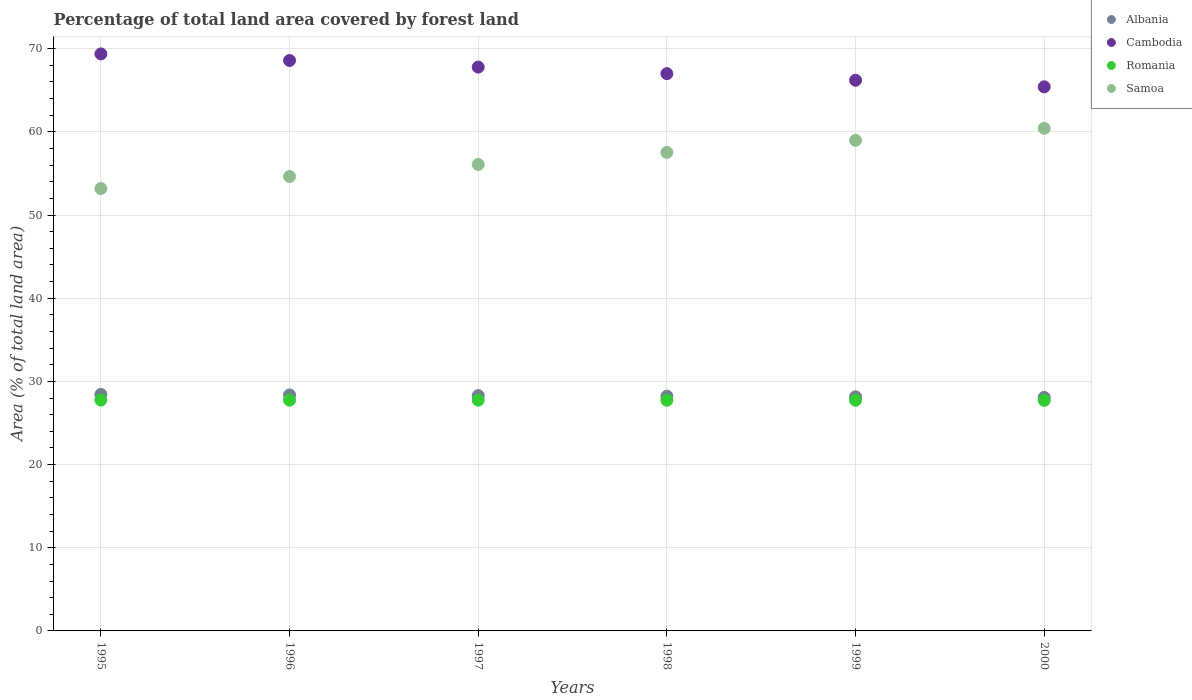How many different coloured dotlines are there?
Offer a terse response. 4. Is the number of dotlines equal to the number of legend labels?
Your answer should be compact. Yes. What is the percentage of forest land in Romania in 1998?
Offer a very short reply. 27.73. Across all years, what is the maximum percentage of forest land in Samoa?
Provide a short and direct response. 60.42. Across all years, what is the minimum percentage of forest land in Cambodia?
Keep it short and to the point. 65.41. What is the total percentage of forest land in Romania in the graph?
Your answer should be very brief. 166.41. What is the difference between the percentage of forest land in Cambodia in 1996 and that in 1997?
Give a very brief answer. 0.79. What is the difference between the percentage of forest land in Samoa in 1998 and the percentage of forest land in Cambodia in 1996?
Make the answer very short. -11.05. What is the average percentage of forest land in Albania per year?
Offer a very short reply. 28.25. In the year 1995, what is the difference between the percentage of forest land in Albania and percentage of forest land in Samoa?
Your answer should be very brief. -24.75. In how many years, is the percentage of forest land in Cambodia greater than 20 %?
Keep it short and to the point. 6. What is the ratio of the percentage of forest land in Samoa in 1995 to that in 1997?
Your answer should be compact. 0.95. Is the percentage of forest land in Samoa in 1995 less than that in 1999?
Offer a very short reply. Yes. Is the difference between the percentage of forest land in Albania in 1995 and 1998 greater than the difference between the percentage of forest land in Samoa in 1995 and 1998?
Make the answer very short. Yes. What is the difference between the highest and the second highest percentage of forest land in Cambodia?
Make the answer very short. 0.79. What is the difference between the highest and the lowest percentage of forest land in Cambodia?
Provide a succinct answer. 3.96. Is the sum of the percentage of forest land in Samoa in 1995 and 1997 greater than the maximum percentage of forest land in Albania across all years?
Offer a terse response. Yes. Is it the case that in every year, the sum of the percentage of forest land in Romania and percentage of forest land in Albania  is greater than the percentage of forest land in Cambodia?
Your answer should be very brief. No. Does the percentage of forest land in Albania monotonically increase over the years?
Your answer should be very brief. No. Is the percentage of forest land in Samoa strictly greater than the percentage of forest land in Romania over the years?
Keep it short and to the point. Yes. How many years are there in the graph?
Offer a very short reply. 6. Where does the legend appear in the graph?
Give a very brief answer. Top right. How are the legend labels stacked?
Your response must be concise. Vertical. What is the title of the graph?
Your answer should be compact. Percentage of total land area covered by forest land. Does "Somalia" appear as one of the legend labels in the graph?
Offer a terse response. No. What is the label or title of the X-axis?
Keep it short and to the point. Years. What is the label or title of the Y-axis?
Provide a short and direct response. Area (% of total land area). What is the Area (% of total land area) of Albania in 1995?
Provide a succinct answer. 28.43. What is the Area (% of total land area) of Cambodia in 1995?
Your answer should be compact. 69.37. What is the Area (% of total land area) of Romania in 1995?
Provide a short and direct response. 27.75. What is the Area (% of total land area) of Samoa in 1995?
Keep it short and to the point. 53.18. What is the Area (% of total land area) in Albania in 1996?
Your answer should be very brief. 28.36. What is the Area (% of total land area) of Cambodia in 1996?
Offer a very short reply. 68.58. What is the Area (% of total land area) of Romania in 1996?
Ensure brevity in your answer.  27.74. What is the Area (% of total land area) of Samoa in 1996?
Keep it short and to the point. 54.63. What is the Area (% of total land area) of Albania in 1997?
Offer a terse response. 28.29. What is the Area (% of total land area) of Cambodia in 1997?
Ensure brevity in your answer.  67.78. What is the Area (% of total land area) in Romania in 1997?
Offer a very short reply. 27.74. What is the Area (% of total land area) of Samoa in 1997?
Offer a very short reply. 56.08. What is the Area (% of total land area) in Albania in 1998?
Offer a very short reply. 28.22. What is the Area (% of total land area) of Cambodia in 1998?
Ensure brevity in your answer.  66.99. What is the Area (% of total land area) in Romania in 1998?
Your response must be concise. 27.73. What is the Area (% of total land area) in Samoa in 1998?
Give a very brief answer. 57.53. What is the Area (% of total land area) of Albania in 1999?
Ensure brevity in your answer.  28.15. What is the Area (% of total land area) of Cambodia in 1999?
Provide a succinct answer. 66.2. What is the Area (% of total land area) in Romania in 1999?
Give a very brief answer. 27.73. What is the Area (% of total land area) in Samoa in 1999?
Offer a very short reply. 58.98. What is the Area (% of total land area) of Albania in 2000?
Provide a short and direct response. 28.08. What is the Area (% of total land area) in Cambodia in 2000?
Your response must be concise. 65.41. What is the Area (% of total land area) of Romania in 2000?
Keep it short and to the point. 27.71. What is the Area (% of total land area) of Samoa in 2000?
Provide a short and direct response. 60.42. Across all years, what is the maximum Area (% of total land area) of Albania?
Give a very brief answer. 28.43. Across all years, what is the maximum Area (% of total land area) of Cambodia?
Your response must be concise. 69.37. Across all years, what is the maximum Area (% of total land area) of Romania?
Your answer should be very brief. 27.75. Across all years, what is the maximum Area (% of total land area) of Samoa?
Provide a succinct answer. 60.42. Across all years, what is the minimum Area (% of total land area) of Albania?
Offer a terse response. 28.08. Across all years, what is the minimum Area (% of total land area) of Cambodia?
Your answer should be very brief. 65.41. Across all years, what is the minimum Area (% of total land area) of Romania?
Offer a terse response. 27.71. Across all years, what is the minimum Area (% of total land area) in Samoa?
Offer a terse response. 53.18. What is the total Area (% of total land area) of Albania in the graph?
Your answer should be very brief. 169.53. What is the total Area (% of total land area) of Cambodia in the graph?
Your response must be concise. 404.33. What is the total Area (% of total land area) in Romania in the graph?
Keep it short and to the point. 166.41. What is the total Area (% of total land area) in Samoa in the graph?
Make the answer very short. 340.81. What is the difference between the Area (% of total land area) in Albania in 1995 and that in 1996?
Provide a short and direct response. 0.07. What is the difference between the Area (% of total land area) of Cambodia in 1995 and that in 1996?
Make the answer very short. 0.79. What is the difference between the Area (% of total land area) of Romania in 1995 and that in 1996?
Offer a terse response. 0.01. What is the difference between the Area (% of total land area) of Samoa in 1995 and that in 1996?
Your answer should be compact. -1.45. What is the difference between the Area (% of total land area) in Albania in 1995 and that in 1997?
Offer a terse response. 0.14. What is the difference between the Area (% of total land area) of Cambodia in 1995 and that in 1997?
Offer a terse response. 1.58. What is the difference between the Area (% of total land area) in Romania in 1995 and that in 1997?
Give a very brief answer. 0.01. What is the difference between the Area (% of total land area) in Samoa in 1995 and that in 1997?
Make the answer very short. -2.9. What is the difference between the Area (% of total land area) in Albania in 1995 and that in 1998?
Give a very brief answer. 0.21. What is the difference between the Area (% of total land area) of Cambodia in 1995 and that in 1998?
Give a very brief answer. 2.38. What is the difference between the Area (% of total land area) in Romania in 1995 and that in 1998?
Your answer should be compact. 0.02. What is the difference between the Area (% of total land area) in Samoa in 1995 and that in 1998?
Offer a very short reply. -4.35. What is the difference between the Area (% of total land area) in Albania in 1995 and that in 1999?
Make the answer very short. 0.28. What is the difference between the Area (% of total land area) of Cambodia in 1995 and that in 1999?
Your answer should be very brief. 3.17. What is the difference between the Area (% of total land area) in Romania in 1995 and that in 1999?
Make the answer very short. 0.02. What is the difference between the Area (% of total land area) of Samoa in 1995 and that in 1999?
Give a very brief answer. -5.8. What is the difference between the Area (% of total land area) in Albania in 1995 and that in 2000?
Provide a succinct answer. 0.36. What is the difference between the Area (% of total land area) of Cambodia in 1995 and that in 2000?
Your answer should be compact. 3.96. What is the difference between the Area (% of total land area) in Romania in 1995 and that in 2000?
Your response must be concise. 0.04. What is the difference between the Area (% of total land area) in Samoa in 1995 and that in 2000?
Your response must be concise. -7.24. What is the difference between the Area (% of total land area) of Albania in 1996 and that in 1997?
Your answer should be very brief. 0.07. What is the difference between the Area (% of total land area) in Cambodia in 1996 and that in 1997?
Offer a very short reply. 0.79. What is the difference between the Area (% of total land area) in Romania in 1996 and that in 1997?
Keep it short and to the point. 0. What is the difference between the Area (% of total land area) in Samoa in 1996 and that in 1997?
Your response must be concise. -1.45. What is the difference between the Area (% of total land area) of Albania in 1996 and that in 1998?
Your response must be concise. 0.14. What is the difference between the Area (% of total land area) in Cambodia in 1996 and that in 1998?
Your answer should be very brief. 1.58. What is the difference between the Area (% of total land area) in Romania in 1996 and that in 1998?
Your answer should be compact. 0.01. What is the difference between the Area (% of total land area) in Samoa in 1996 and that in 1998?
Your answer should be very brief. -2.9. What is the difference between the Area (% of total land area) in Albania in 1996 and that in 1999?
Give a very brief answer. 0.21. What is the difference between the Area (% of total land area) in Cambodia in 1996 and that in 1999?
Provide a short and direct response. 2.38. What is the difference between the Area (% of total land area) of Romania in 1996 and that in 1999?
Provide a short and direct response. 0.02. What is the difference between the Area (% of total land area) of Samoa in 1996 and that in 1999?
Your response must be concise. -4.35. What is the difference between the Area (% of total land area) of Albania in 1996 and that in 2000?
Provide a succinct answer. 0.28. What is the difference between the Area (% of total land area) of Cambodia in 1996 and that in 2000?
Offer a very short reply. 3.17. What is the difference between the Area (% of total land area) of Romania in 1996 and that in 2000?
Your response must be concise. 0.03. What is the difference between the Area (% of total land area) of Samoa in 1996 and that in 2000?
Ensure brevity in your answer.  -5.8. What is the difference between the Area (% of total land area) in Albania in 1997 and that in 1998?
Keep it short and to the point. 0.07. What is the difference between the Area (% of total land area) in Cambodia in 1997 and that in 1998?
Provide a short and direct response. 0.79. What is the difference between the Area (% of total land area) of Romania in 1997 and that in 1998?
Make the answer very short. 0.01. What is the difference between the Area (% of total land area) of Samoa in 1997 and that in 1998?
Make the answer very short. -1.45. What is the difference between the Area (% of total land area) of Albania in 1997 and that in 1999?
Make the answer very short. 0.14. What is the difference between the Area (% of total land area) in Cambodia in 1997 and that in 1999?
Your answer should be very brief. 1.58. What is the difference between the Area (% of total land area) in Romania in 1997 and that in 1999?
Your answer should be very brief. 0.01. What is the difference between the Area (% of total land area) in Samoa in 1997 and that in 1999?
Your response must be concise. -2.9. What is the difference between the Area (% of total land area) of Albania in 1997 and that in 2000?
Give a very brief answer. 0.21. What is the difference between the Area (% of total land area) of Cambodia in 1997 and that in 2000?
Your answer should be compact. 2.38. What is the difference between the Area (% of total land area) in Romania in 1997 and that in 2000?
Provide a succinct answer. 0.03. What is the difference between the Area (% of total land area) of Samoa in 1997 and that in 2000?
Your response must be concise. -4.35. What is the difference between the Area (% of total land area) of Albania in 1998 and that in 1999?
Provide a short and direct response. 0.07. What is the difference between the Area (% of total land area) in Cambodia in 1998 and that in 1999?
Provide a succinct answer. 0.79. What is the difference between the Area (% of total land area) in Romania in 1998 and that in 1999?
Keep it short and to the point. 0. What is the difference between the Area (% of total land area) in Samoa in 1998 and that in 1999?
Your response must be concise. -1.45. What is the difference between the Area (% of total land area) of Albania in 1998 and that in 2000?
Provide a short and direct response. 0.14. What is the difference between the Area (% of total land area) of Cambodia in 1998 and that in 2000?
Ensure brevity in your answer.  1.58. What is the difference between the Area (% of total land area) in Romania in 1998 and that in 2000?
Ensure brevity in your answer.  0.02. What is the difference between the Area (% of total land area) in Samoa in 1998 and that in 2000?
Offer a very short reply. -2.9. What is the difference between the Area (% of total land area) of Albania in 1999 and that in 2000?
Your answer should be very brief. 0.07. What is the difference between the Area (% of total land area) of Cambodia in 1999 and that in 2000?
Offer a very short reply. 0.79. What is the difference between the Area (% of total land area) of Romania in 1999 and that in 2000?
Make the answer very short. 0.02. What is the difference between the Area (% of total land area) of Samoa in 1999 and that in 2000?
Make the answer very short. -1.45. What is the difference between the Area (% of total land area) in Albania in 1995 and the Area (% of total land area) in Cambodia in 1996?
Offer a terse response. -40.14. What is the difference between the Area (% of total land area) in Albania in 1995 and the Area (% of total land area) in Romania in 1996?
Make the answer very short. 0.69. What is the difference between the Area (% of total land area) in Albania in 1995 and the Area (% of total land area) in Samoa in 1996?
Your answer should be very brief. -26.2. What is the difference between the Area (% of total land area) in Cambodia in 1995 and the Area (% of total land area) in Romania in 1996?
Make the answer very short. 41.62. What is the difference between the Area (% of total land area) of Cambodia in 1995 and the Area (% of total land area) of Samoa in 1996?
Your answer should be compact. 14.74. What is the difference between the Area (% of total land area) of Romania in 1995 and the Area (% of total land area) of Samoa in 1996?
Ensure brevity in your answer.  -26.88. What is the difference between the Area (% of total land area) of Albania in 1995 and the Area (% of total land area) of Cambodia in 1997?
Your response must be concise. -39.35. What is the difference between the Area (% of total land area) in Albania in 1995 and the Area (% of total land area) in Romania in 1997?
Provide a short and direct response. 0.69. What is the difference between the Area (% of total land area) of Albania in 1995 and the Area (% of total land area) of Samoa in 1997?
Provide a succinct answer. -27.65. What is the difference between the Area (% of total land area) of Cambodia in 1995 and the Area (% of total land area) of Romania in 1997?
Your answer should be very brief. 41.63. What is the difference between the Area (% of total land area) of Cambodia in 1995 and the Area (% of total land area) of Samoa in 1997?
Your response must be concise. 13.29. What is the difference between the Area (% of total land area) in Romania in 1995 and the Area (% of total land area) in Samoa in 1997?
Make the answer very short. -28.33. What is the difference between the Area (% of total land area) of Albania in 1995 and the Area (% of total land area) of Cambodia in 1998?
Make the answer very short. -38.56. What is the difference between the Area (% of total land area) in Albania in 1995 and the Area (% of total land area) in Romania in 1998?
Offer a terse response. 0.7. What is the difference between the Area (% of total land area) in Albania in 1995 and the Area (% of total land area) in Samoa in 1998?
Offer a terse response. -29.09. What is the difference between the Area (% of total land area) in Cambodia in 1995 and the Area (% of total land area) in Romania in 1998?
Ensure brevity in your answer.  41.64. What is the difference between the Area (% of total land area) in Cambodia in 1995 and the Area (% of total land area) in Samoa in 1998?
Keep it short and to the point. 11.84. What is the difference between the Area (% of total land area) of Romania in 1995 and the Area (% of total land area) of Samoa in 1998?
Offer a terse response. -29.78. What is the difference between the Area (% of total land area) of Albania in 1995 and the Area (% of total land area) of Cambodia in 1999?
Provide a succinct answer. -37.77. What is the difference between the Area (% of total land area) in Albania in 1995 and the Area (% of total land area) in Romania in 1999?
Make the answer very short. 0.7. What is the difference between the Area (% of total land area) of Albania in 1995 and the Area (% of total land area) of Samoa in 1999?
Keep it short and to the point. -30.54. What is the difference between the Area (% of total land area) of Cambodia in 1995 and the Area (% of total land area) of Romania in 1999?
Offer a very short reply. 41.64. What is the difference between the Area (% of total land area) of Cambodia in 1995 and the Area (% of total land area) of Samoa in 1999?
Give a very brief answer. 10.39. What is the difference between the Area (% of total land area) in Romania in 1995 and the Area (% of total land area) in Samoa in 1999?
Give a very brief answer. -31.22. What is the difference between the Area (% of total land area) in Albania in 1995 and the Area (% of total land area) in Cambodia in 2000?
Provide a succinct answer. -36.98. What is the difference between the Area (% of total land area) of Albania in 1995 and the Area (% of total land area) of Romania in 2000?
Your answer should be very brief. 0.72. What is the difference between the Area (% of total land area) in Albania in 1995 and the Area (% of total land area) in Samoa in 2000?
Your answer should be very brief. -31.99. What is the difference between the Area (% of total land area) in Cambodia in 1995 and the Area (% of total land area) in Romania in 2000?
Ensure brevity in your answer.  41.66. What is the difference between the Area (% of total land area) in Cambodia in 1995 and the Area (% of total land area) in Samoa in 2000?
Make the answer very short. 8.94. What is the difference between the Area (% of total land area) of Romania in 1995 and the Area (% of total land area) of Samoa in 2000?
Your answer should be very brief. -32.67. What is the difference between the Area (% of total land area) in Albania in 1996 and the Area (% of total land area) in Cambodia in 1997?
Provide a succinct answer. -39.42. What is the difference between the Area (% of total land area) in Albania in 1996 and the Area (% of total land area) in Romania in 1997?
Provide a succinct answer. 0.62. What is the difference between the Area (% of total land area) in Albania in 1996 and the Area (% of total land area) in Samoa in 1997?
Offer a very short reply. -27.72. What is the difference between the Area (% of total land area) of Cambodia in 1996 and the Area (% of total land area) of Romania in 1997?
Give a very brief answer. 40.84. What is the difference between the Area (% of total land area) in Cambodia in 1996 and the Area (% of total land area) in Samoa in 1997?
Make the answer very short. 12.5. What is the difference between the Area (% of total land area) of Romania in 1996 and the Area (% of total land area) of Samoa in 1997?
Make the answer very short. -28.33. What is the difference between the Area (% of total land area) of Albania in 1996 and the Area (% of total land area) of Cambodia in 1998?
Give a very brief answer. -38.63. What is the difference between the Area (% of total land area) of Albania in 1996 and the Area (% of total land area) of Romania in 1998?
Keep it short and to the point. 0.63. What is the difference between the Area (% of total land area) of Albania in 1996 and the Area (% of total land area) of Samoa in 1998?
Ensure brevity in your answer.  -29.17. What is the difference between the Area (% of total land area) of Cambodia in 1996 and the Area (% of total land area) of Romania in 1998?
Offer a terse response. 40.84. What is the difference between the Area (% of total land area) of Cambodia in 1996 and the Area (% of total land area) of Samoa in 1998?
Offer a very short reply. 11.05. What is the difference between the Area (% of total land area) in Romania in 1996 and the Area (% of total land area) in Samoa in 1998?
Your answer should be compact. -29.78. What is the difference between the Area (% of total land area) in Albania in 1996 and the Area (% of total land area) in Cambodia in 1999?
Offer a very short reply. -37.84. What is the difference between the Area (% of total land area) of Albania in 1996 and the Area (% of total land area) of Romania in 1999?
Make the answer very short. 0.63. What is the difference between the Area (% of total land area) in Albania in 1996 and the Area (% of total land area) in Samoa in 1999?
Offer a very short reply. -30.61. What is the difference between the Area (% of total land area) in Cambodia in 1996 and the Area (% of total land area) in Romania in 1999?
Provide a short and direct response. 40.85. What is the difference between the Area (% of total land area) of Cambodia in 1996 and the Area (% of total land area) of Samoa in 1999?
Offer a very short reply. 9.6. What is the difference between the Area (% of total land area) of Romania in 1996 and the Area (% of total land area) of Samoa in 1999?
Your answer should be compact. -31.23. What is the difference between the Area (% of total land area) in Albania in 1996 and the Area (% of total land area) in Cambodia in 2000?
Ensure brevity in your answer.  -37.05. What is the difference between the Area (% of total land area) of Albania in 1996 and the Area (% of total land area) of Romania in 2000?
Make the answer very short. 0.65. What is the difference between the Area (% of total land area) in Albania in 1996 and the Area (% of total land area) in Samoa in 2000?
Offer a terse response. -32.06. What is the difference between the Area (% of total land area) of Cambodia in 1996 and the Area (% of total land area) of Romania in 2000?
Your answer should be compact. 40.86. What is the difference between the Area (% of total land area) of Cambodia in 1996 and the Area (% of total land area) of Samoa in 2000?
Make the answer very short. 8.15. What is the difference between the Area (% of total land area) in Romania in 1996 and the Area (% of total land area) in Samoa in 2000?
Your answer should be very brief. -32.68. What is the difference between the Area (% of total land area) of Albania in 1997 and the Area (% of total land area) of Cambodia in 1998?
Make the answer very short. -38.7. What is the difference between the Area (% of total land area) in Albania in 1997 and the Area (% of total land area) in Romania in 1998?
Your response must be concise. 0.56. What is the difference between the Area (% of total land area) in Albania in 1997 and the Area (% of total land area) in Samoa in 1998?
Provide a short and direct response. -29.24. What is the difference between the Area (% of total land area) in Cambodia in 1997 and the Area (% of total land area) in Romania in 1998?
Your answer should be compact. 40.05. What is the difference between the Area (% of total land area) of Cambodia in 1997 and the Area (% of total land area) of Samoa in 1998?
Give a very brief answer. 10.26. What is the difference between the Area (% of total land area) of Romania in 1997 and the Area (% of total land area) of Samoa in 1998?
Provide a succinct answer. -29.79. What is the difference between the Area (% of total land area) of Albania in 1997 and the Area (% of total land area) of Cambodia in 1999?
Give a very brief answer. -37.91. What is the difference between the Area (% of total land area) of Albania in 1997 and the Area (% of total land area) of Romania in 1999?
Ensure brevity in your answer.  0.56. What is the difference between the Area (% of total land area) of Albania in 1997 and the Area (% of total land area) of Samoa in 1999?
Keep it short and to the point. -30.69. What is the difference between the Area (% of total land area) of Cambodia in 1997 and the Area (% of total land area) of Romania in 1999?
Ensure brevity in your answer.  40.06. What is the difference between the Area (% of total land area) of Cambodia in 1997 and the Area (% of total land area) of Samoa in 1999?
Offer a terse response. 8.81. What is the difference between the Area (% of total land area) in Romania in 1997 and the Area (% of total land area) in Samoa in 1999?
Give a very brief answer. -31.23. What is the difference between the Area (% of total land area) in Albania in 1997 and the Area (% of total land area) in Cambodia in 2000?
Give a very brief answer. -37.12. What is the difference between the Area (% of total land area) in Albania in 1997 and the Area (% of total land area) in Romania in 2000?
Provide a short and direct response. 0.58. What is the difference between the Area (% of total land area) in Albania in 1997 and the Area (% of total land area) in Samoa in 2000?
Offer a very short reply. -32.13. What is the difference between the Area (% of total land area) of Cambodia in 1997 and the Area (% of total land area) of Romania in 2000?
Keep it short and to the point. 40.07. What is the difference between the Area (% of total land area) of Cambodia in 1997 and the Area (% of total land area) of Samoa in 2000?
Your answer should be compact. 7.36. What is the difference between the Area (% of total land area) of Romania in 1997 and the Area (% of total land area) of Samoa in 2000?
Your answer should be compact. -32.68. What is the difference between the Area (% of total land area) of Albania in 1998 and the Area (% of total land area) of Cambodia in 1999?
Your response must be concise. -37.98. What is the difference between the Area (% of total land area) in Albania in 1998 and the Area (% of total land area) in Romania in 1999?
Give a very brief answer. 0.49. What is the difference between the Area (% of total land area) of Albania in 1998 and the Area (% of total land area) of Samoa in 1999?
Provide a succinct answer. -30.76. What is the difference between the Area (% of total land area) in Cambodia in 1998 and the Area (% of total land area) in Romania in 1999?
Your response must be concise. 39.26. What is the difference between the Area (% of total land area) of Cambodia in 1998 and the Area (% of total land area) of Samoa in 1999?
Your response must be concise. 8.02. What is the difference between the Area (% of total land area) of Romania in 1998 and the Area (% of total land area) of Samoa in 1999?
Keep it short and to the point. -31.24. What is the difference between the Area (% of total land area) in Albania in 1998 and the Area (% of total land area) in Cambodia in 2000?
Give a very brief answer. -37.19. What is the difference between the Area (% of total land area) in Albania in 1998 and the Area (% of total land area) in Romania in 2000?
Provide a succinct answer. 0.51. What is the difference between the Area (% of total land area) in Albania in 1998 and the Area (% of total land area) in Samoa in 2000?
Your answer should be compact. -32.21. What is the difference between the Area (% of total land area) of Cambodia in 1998 and the Area (% of total land area) of Romania in 2000?
Make the answer very short. 39.28. What is the difference between the Area (% of total land area) of Cambodia in 1998 and the Area (% of total land area) of Samoa in 2000?
Make the answer very short. 6.57. What is the difference between the Area (% of total land area) in Romania in 1998 and the Area (% of total land area) in Samoa in 2000?
Keep it short and to the point. -32.69. What is the difference between the Area (% of total land area) of Albania in 1999 and the Area (% of total land area) of Cambodia in 2000?
Ensure brevity in your answer.  -37.26. What is the difference between the Area (% of total land area) of Albania in 1999 and the Area (% of total land area) of Romania in 2000?
Offer a very short reply. 0.43. What is the difference between the Area (% of total land area) in Albania in 1999 and the Area (% of total land area) in Samoa in 2000?
Provide a short and direct response. -32.28. What is the difference between the Area (% of total land area) of Cambodia in 1999 and the Area (% of total land area) of Romania in 2000?
Keep it short and to the point. 38.49. What is the difference between the Area (% of total land area) in Cambodia in 1999 and the Area (% of total land area) in Samoa in 2000?
Keep it short and to the point. 5.78. What is the difference between the Area (% of total land area) of Romania in 1999 and the Area (% of total land area) of Samoa in 2000?
Keep it short and to the point. -32.7. What is the average Area (% of total land area) of Albania per year?
Offer a very short reply. 28.25. What is the average Area (% of total land area) of Cambodia per year?
Offer a very short reply. 67.39. What is the average Area (% of total land area) in Romania per year?
Give a very brief answer. 27.74. What is the average Area (% of total land area) in Samoa per year?
Provide a short and direct response. 56.8. In the year 1995, what is the difference between the Area (% of total land area) in Albania and Area (% of total land area) in Cambodia?
Your response must be concise. -40.94. In the year 1995, what is the difference between the Area (% of total land area) of Albania and Area (% of total land area) of Romania?
Give a very brief answer. 0.68. In the year 1995, what is the difference between the Area (% of total land area) in Albania and Area (% of total land area) in Samoa?
Keep it short and to the point. -24.75. In the year 1995, what is the difference between the Area (% of total land area) of Cambodia and Area (% of total land area) of Romania?
Make the answer very short. 41.62. In the year 1995, what is the difference between the Area (% of total land area) in Cambodia and Area (% of total land area) in Samoa?
Provide a short and direct response. 16.19. In the year 1995, what is the difference between the Area (% of total land area) in Romania and Area (% of total land area) in Samoa?
Offer a terse response. -25.43. In the year 1996, what is the difference between the Area (% of total land area) of Albania and Area (% of total land area) of Cambodia?
Offer a terse response. -40.22. In the year 1996, what is the difference between the Area (% of total land area) of Albania and Area (% of total land area) of Romania?
Make the answer very short. 0.62. In the year 1996, what is the difference between the Area (% of total land area) of Albania and Area (% of total land area) of Samoa?
Offer a terse response. -26.27. In the year 1996, what is the difference between the Area (% of total land area) in Cambodia and Area (% of total land area) in Romania?
Give a very brief answer. 40.83. In the year 1996, what is the difference between the Area (% of total land area) in Cambodia and Area (% of total land area) in Samoa?
Ensure brevity in your answer.  13.95. In the year 1996, what is the difference between the Area (% of total land area) in Romania and Area (% of total land area) in Samoa?
Provide a succinct answer. -26.88. In the year 1997, what is the difference between the Area (% of total land area) in Albania and Area (% of total land area) in Cambodia?
Provide a succinct answer. -39.49. In the year 1997, what is the difference between the Area (% of total land area) in Albania and Area (% of total land area) in Romania?
Make the answer very short. 0.55. In the year 1997, what is the difference between the Area (% of total land area) of Albania and Area (% of total land area) of Samoa?
Give a very brief answer. -27.79. In the year 1997, what is the difference between the Area (% of total land area) of Cambodia and Area (% of total land area) of Romania?
Offer a very short reply. 40.04. In the year 1997, what is the difference between the Area (% of total land area) of Cambodia and Area (% of total land area) of Samoa?
Your response must be concise. 11.71. In the year 1997, what is the difference between the Area (% of total land area) in Romania and Area (% of total land area) in Samoa?
Make the answer very short. -28.34. In the year 1998, what is the difference between the Area (% of total land area) of Albania and Area (% of total land area) of Cambodia?
Provide a succinct answer. -38.77. In the year 1998, what is the difference between the Area (% of total land area) in Albania and Area (% of total land area) in Romania?
Keep it short and to the point. 0.49. In the year 1998, what is the difference between the Area (% of total land area) in Albania and Area (% of total land area) in Samoa?
Provide a succinct answer. -29.31. In the year 1998, what is the difference between the Area (% of total land area) of Cambodia and Area (% of total land area) of Romania?
Offer a very short reply. 39.26. In the year 1998, what is the difference between the Area (% of total land area) of Cambodia and Area (% of total land area) of Samoa?
Your response must be concise. 9.47. In the year 1998, what is the difference between the Area (% of total land area) of Romania and Area (% of total land area) of Samoa?
Offer a very short reply. -29.79. In the year 1999, what is the difference between the Area (% of total land area) in Albania and Area (% of total land area) in Cambodia?
Keep it short and to the point. -38.05. In the year 1999, what is the difference between the Area (% of total land area) of Albania and Area (% of total land area) of Romania?
Ensure brevity in your answer.  0.42. In the year 1999, what is the difference between the Area (% of total land area) of Albania and Area (% of total land area) of Samoa?
Offer a terse response. -30.83. In the year 1999, what is the difference between the Area (% of total land area) of Cambodia and Area (% of total land area) of Romania?
Offer a terse response. 38.47. In the year 1999, what is the difference between the Area (% of total land area) of Cambodia and Area (% of total land area) of Samoa?
Provide a short and direct response. 7.23. In the year 1999, what is the difference between the Area (% of total land area) in Romania and Area (% of total land area) in Samoa?
Keep it short and to the point. -31.25. In the year 2000, what is the difference between the Area (% of total land area) in Albania and Area (% of total land area) in Cambodia?
Keep it short and to the point. -37.33. In the year 2000, what is the difference between the Area (% of total land area) of Albania and Area (% of total land area) of Romania?
Provide a succinct answer. 0.36. In the year 2000, what is the difference between the Area (% of total land area) of Albania and Area (% of total land area) of Samoa?
Keep it short and to the point. -32.35. In the year 2000, what is the difference between the Area (% of total land area) of Cambodia and Area (% of total land area) of Romania?
Your answer should be compact. 37.7. In the year 2000, what is the difference between the Area (% of total land area) in Cambodia and Area (% of total land area) in Samoa?
Make the answer very short. 4.99. In the year 2000, what is the difference between the Area (% of total land area) of Romania and Area (% of total land area) of Samoa?
Offer a very short reply. -32.71. What is the ratio of the Area (% of total land area) in Cambodia in 1995 to that in 1996?
Give a very brief answer. 1.01. What is the ratio of the Area (% of total land area) in Samoa in 1995 to that in 1996?
Give a very brief answer. 0.97. What is the ratio of the Area (% of total land area) in Albania in 1995 to that in 1997?
Keep it short and to the point. 1. What is the ratio of the Area (% of total land area) in Cambodia in 1995 to that in 1997?
Your answer should be very brief. 1.02. What is the ratio of the Area (% of total land area) of Samoa in 1995 to that in 1997?
Keep it short and to the point. 0.95. What is the ratio of the Area (% of total land area) of Albania in 1995 to that in 1998?
Give a very brief answer. 1.01. What is the ratio of the Area (% of total land area) of Cambodia in 1995 to that in 1998?
Offer a very short reply. 1.04. What is the ratio of the Area (% of total land area) of Samoa in 1995 to that in 1998?
Your response must be concise. 0.92. What is the ratio of the Area (% of total land area) in Cambodia in 1995 to that in 1999?
Your answer should be very brief. 1.05. What is the ratio of the Area (% of total land area) of Samoa in 1995 to that in 1999?
Ensure brevity in your answer.  0.9. What is the ratio of the Area (% of total land area) in Albania in 1995 to that in 2000?
Provide a short and direct response. 1.01. What is the ratio of the Area (% of total land area) in Cambodia in 1995 to that in 2000?
Your answer should be very brief. 1.06. What is the ratio of the Area (% of total land area) of Romania in 1995 to that in 2000?
Your answer should be very brief. 1. What is the ratio of the Area (% of total land area) of Samoa in 1995 to that in 2000?
Ensure brevity in your answer.  0.88. What is the ratio of the Area (% of total land area) in Cambodia in 1996 to that in 1997?
Make the answer very short. 1.01. What is the ratio of the Area (% of total land area) of Romania in 1996 to that in 1997?
Keep it short and to the point. 1. What is the ratio of the Area (% of total land area) in Samoa in 1996 to that in 1997?
Offer a terse response. 0.97. What is the ratio of the Area (% of total land area) of Cambodia in 1996 to that in 1998?
Your response must be concise. 1.02. What is the ratio of the Area (% of total land area) of Romania in 1996 to that in 1998?
Make the answer very short. 1. What is the ratio of the Area (% of total land area) of Samoa in 1996 to that in 1998?
Your response must be concise. 0.95. What is the ratio of the Area (% of total land area) in Albania in 1996 to that in 1999?
Your answer should be very brief. 1.01. What is the ratio of the Area (% of total land area) of Cambodia in 1996 to that in 1999?
Your answer should be compact. 1.04. What is the ratio of the Area (% of total land area) in Romania in 1996 to that in 1999?
Your answer should be very brief. 1. What is the ratio of the Area (% of total land area) of Samoa in 1996 to that in 1999?
Give a very brief answer. 0.93. What is the ratio of the Area (% of total land area) in Albania in 1996 to that in 2000?
Your answer should be very brief. 1.01. What is the ratio of the Area (% of total land area) in Cambodia in 1996 to that in 2000?
Provide a succinct answer. 1.05. What is the ratio of the Area (% of total land area) of Romania in 1996 to that in 2000?
Ensure brevity in your answer.  1. What is the ratio of the Area (% of total land area) of Samoa in 1996 to that in 2000?
Give a very brief answer. 0.9. What is the ratio of the Area (% of total land area) in Albania in 1997 to that in 1998?
Give a very brief answer. 1. What is the ratio of the Area (% of total land area) of Cambodia in 1997 to that in 1998?
Provide a short and direct response. 1.01. What is the ratio of the Area (% of total land area) in Romania in 1997 to that in 1998?
Provide a short and direct response. 1. What is the ratio of the Area (% of total land area) of Samoa in 1997 to that in 1998?
Give a very brief answer. 0.97. What is the ratio of the Area (% of total land area) in Cambodia in 1997 to that in 1999?
Provide a succinct answer. 1.02. What is the ratio of the Area (% of total land area) in Romania in 1997 to that in 1999?
Ensure brevity in your answer.  1. What is the ratio of the Area (% of total land area) of Samoa in 1997 to that in 1999?
Make the answer very short. 0.95. What is the ratio of the Area (% of total land area) in Albania in 1997 to that in 2000?
Offer a terse response. 1.01. What is the ratio of the Area (% of total land area) of Cambodia in 1997 to that in 2000?
Provide a succinct answer. 1.04. What is the ratio of the Area (% of total land area) of Romania in 1997 to that in 2000?
Give a very brief answer. 1. What is the ratio of the Area (% of total land area) of Samoa in 1997 to that in 2000?
Your response must be concise. 0.93. What is the ratio of the Area (% of total land area) in Cambodia in 1998 to that in 1999?
Offer a very short reply. 1.01. What is the ratio of the Area (% of total land area) in Samoa in 1998 to that in 1999?
Ensure brevity in your answer.  0.98. What is the ratio of the Area (% of total land area) in Cambodia in 1998 to that in 2000?
Your answer should be very brief. 1.02. What is the ratio of the Area (% of total land area) in Albania in 1999 to that in 2000?
Offer a terse response. 1. What is the ratio of the Area (% of total land area) in Cambodia in 1999 to that in 2000?
Provide a short and direct response. 1.01. What is the ratio of the Area (% of total land area) of Romania in 1999 to that in 2000?
Provide a short and direct response. 1. What is the ratio of the Area (% of total land area) in Samoa in 1999 to that in 2000?
Keep it short and to the point. 0.98. What is the difference between the highest and the second highest Area (% of total land area) of Albania?
Provide a succinct answer. 0.07. What is the difference between the highest and the second highest Area (% of total land area) in Cambodia?
Your response must be concise. 0.79. What is the difference between the highest and the second highest Area (% of total land area) in Romania?
Your response must be concise. 0.01. What is the difference between the highest and the second highest Area (% of total land area) in Samoa?
Ensure brevity in your answer.  1.45. What is the difference between the highest and the lowest Area (% of total land area) of Albania?
Your answer should be very brief. 0.36. What is the difference between the highest and the lowest Area (% of total land area) of Cambodia?
Provide a succinct answer. 3.96. What is the difference between the highest and the lowest Area (% of total land area) in Romania?
Your answer should be very brief. 0.04. What is the difference between the highest and the lowest Area (% of total land area) of Samoa?
Give a very brief answer. 7.24. 